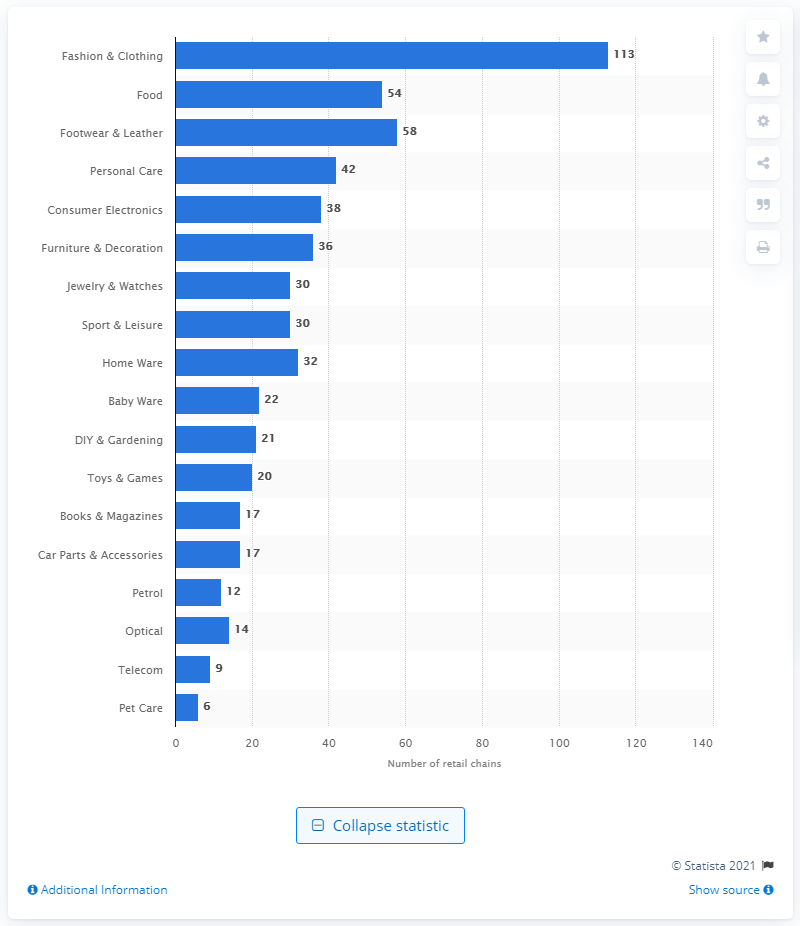Indicate a few pertinent items in this graphic. There were 58 retail chains in the footwear and leather industry. 